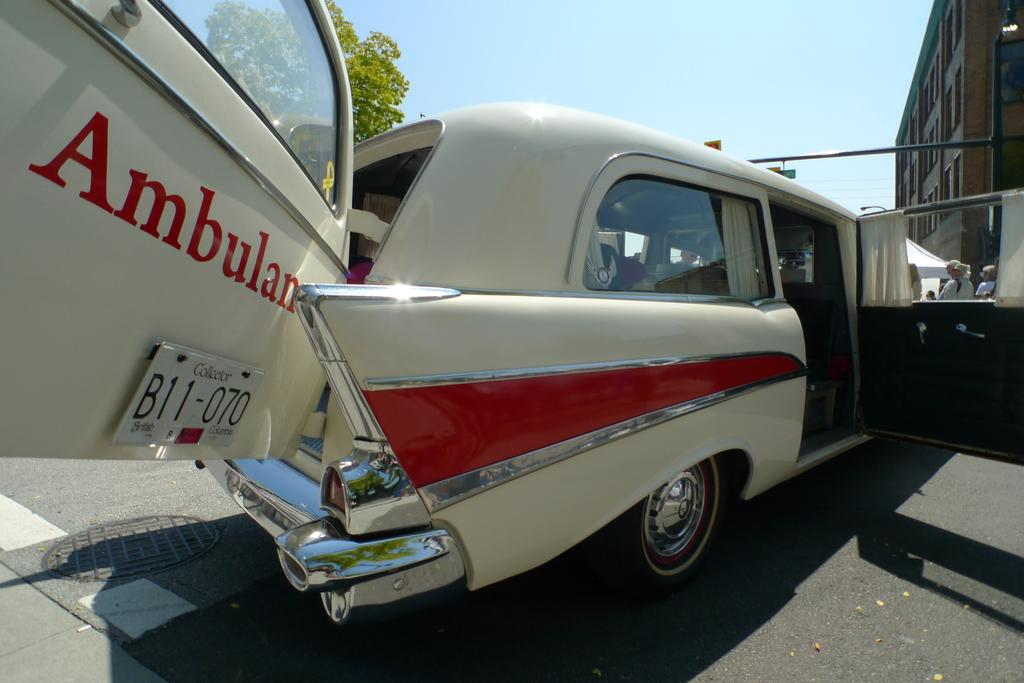What type of vehicles can be seen on the road in the image? There are motor vehicles on the road in the image. What objects are present to provide shade in the image? Parasols are present in the image. What are the people in the image doing? There are persons standing on the road in the image. What type of structures can be seen in the image? There are buildings in the image. What type of vegetation is visible in the image? Trees are visible in the image. What part of the natural environment is visible in the image? The sky is visible in the image. How much salt is visible on the road in the image? There is no salt visible on the road in the image. What type of water feature can be seen in the image? There is no water feature present in the image. 